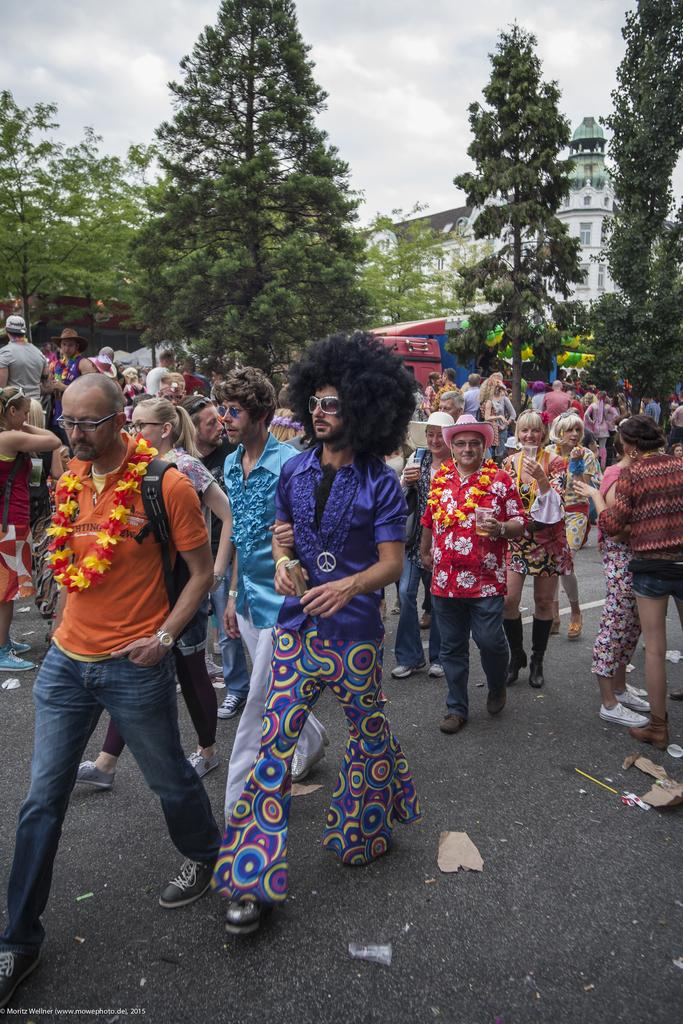What is happening on the road in the image? There are people on the road in the image. What are some of the people doing in the image? Some of the people are holding objects in their hands. What can be seen in the distance in the image? There are buildings and trees visible in the background of the image. What type of memory is being used by the people in the image? There is no indication in the image that the people are using any specific type of memory. Can you see any blood on the road in the image? There is no blood visible on the road in the image. 